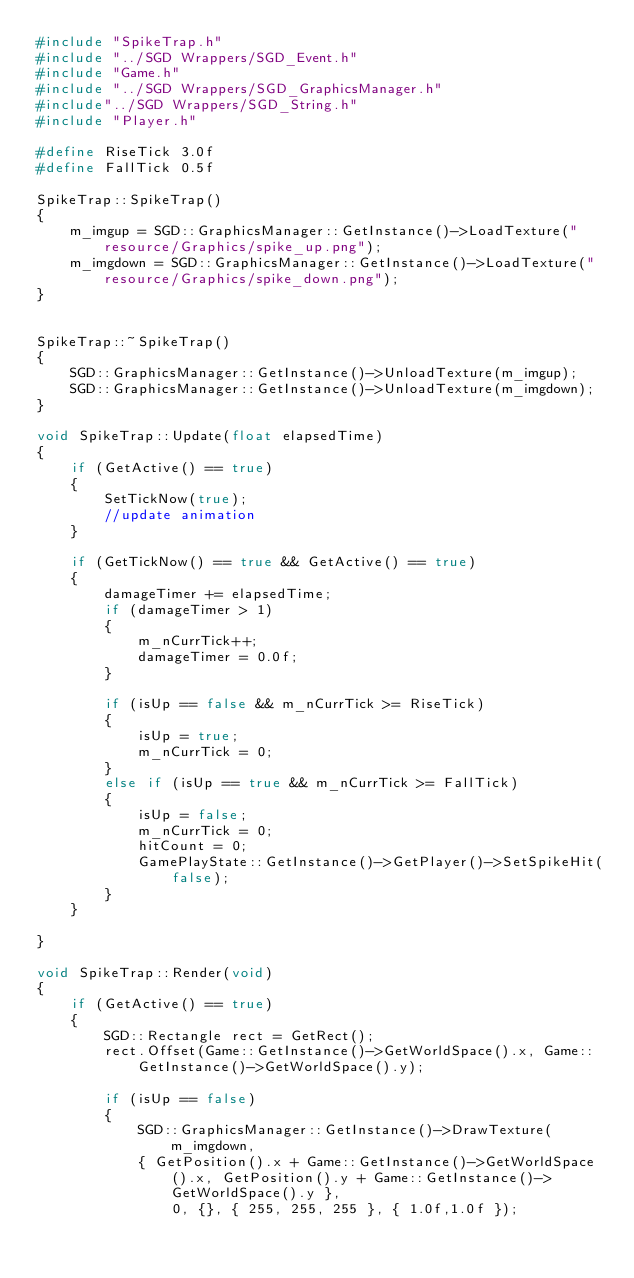Convert code to text. <code><loc_0><loc_0><loc_500><loc_500><_C++_>#include "SpikeTrap.h"
#include "../SGD Wrappers/SGD_Event.h"
#include "Game.h"
#include "../SGD Wrappers/SGD_GraphicsManager.h"
#include"../SGD Wrappers/SGD_String.h"
#include "Player.h"

#define RiseTick 3.0f
#define FallTick 0.5f

SpikeTrap::SpikeTrap()
{
	m_imgup = SGD::GraphicsManager::GetInstance()->LoadTexture("resource/Graphics/spike_up.png");
	m_imgdown = SGD::GraphicsManager::GetInstance()->LoadTexture("resource/Graphics/spike_down.png");
}


SpikeTrap::~SpikeTrap()
{
	SGD::GraphicsManager::GetInstance()->UnloadTexture(m_imgup);
	SGD::GraphicsManager::GetInstance()->UnloadTexture(m_imgdown);
}

void SpikeTrap::Update(float elapsedTime)
{
	if (GetActive() == true)
	{
		SetTickNow(true);
		//update animation
	}

	if (GetTickNow() == true && GetActive() == true)
	{
		damageTimer += elapsedTime;
		if (damageTimer > 1)
		{
			m_nCurrTick++;
			damageTimer = 0.0f;
		}

		if (isUp == false && m_nCurrTick >= RiseTick)
		{
			isUp = true;
			m_nCurrTick = 0;
		}
		else if (isUp == true && m_nCurrTick >= FallTick)
		{
			isUp = false;
			m_nCurrTick = 0;
			hitCount = 0;
			GamePlayState::GetInstance()->GetPlayer()->SetSpikeHit(false);
		}
	}

}

void SpikeTrap::Render(void)
{
	if (GetActive() == true)
	{
		SGD::Rectangle rect = GetRect();
		rect.Offset(Game::GetInstance()->GetWorldSpace().x, Game::GetInstance()->GetWorldSpace().y);

		if (isUp == false)
		{
			SGD::GraphicsManager::GetInstance()->DrawTexture(m_imgdown, 
			{ GetPosition().x + Game::GetInstance()->GetWorldSpace().x, GetPosition().y + Game::GetInstance()->GetWorldSpace().y },
				0, {}, { 255, 255, 255 }, { 1.0f,1.0f });</code> 